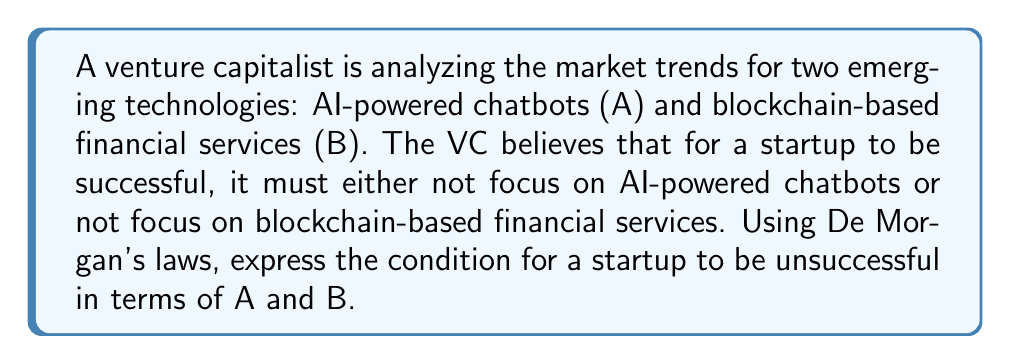Give your solution to this math problem. Let's approach this step-by-step:

1) First, let's define our variables:
   A: The startup focuses on AI-powered chatbots
   B: The startup focuses on blockchain-based financial services

2) The VC's belief can be expressed as: For success, $(\neg A) \lor (\neg B)$

3) Therefore, for a startup to be unsuccessful, we need the negation of this condition:
   $\neg((\neg A) \lor (\neg B))$

4) This is where we apply De Morgan's laws. The first law states:
   $\neg(P \lor Q) \equiv (\neg P) \land (\neg Q)$

5) Applying this to our expression:
   $\neg((\neg A) \lor (\neg B)) \equiv (\neg(\neg A)) \land (\neg(\neg B))$

6) The double negation cancels out:
   $(\neg(\neg A)) \land (\neg(\neg B)) \equiv A \land B$

Therefore, according to De Morgan's laws, a startup will be unsuccessful if it focuses on both AI-powered chatbots AND blockchain-based financial services.
Answer: $A \land B$ 